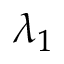<formula> <loc_0><loc_0><loc_500><loc_500>\lambda _ { 1 }</formula> 